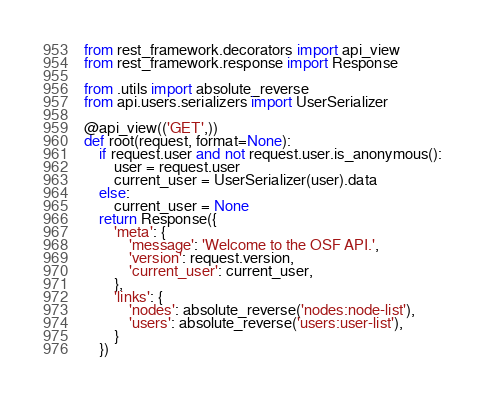<code> <loc_0><loc_0><loc_500><loc_500><_Python_>from rest_framework.decorators import api_view
from rest_framework.response import Response

from .utils import absolute_reverse
from api.users.serializers import UserSerializer

@api_view(('GET',))
def root(request, format=None):
    if request.user and not request.user.is_anonymous():
        user = request.user
        current_user = UserSerializer(user).data
    else:
        current_user = None
    return Response({
        'meta': {
            'message': 'Welcome to the OSF API.',
            'version': request.version,
            'current_user': current_user,
        },
        'links': {
            'nodes': absolute_reverse('nodes:node-list'),
            'users': absolute_reverse('users:user-list'),
        }
    })
</code> 